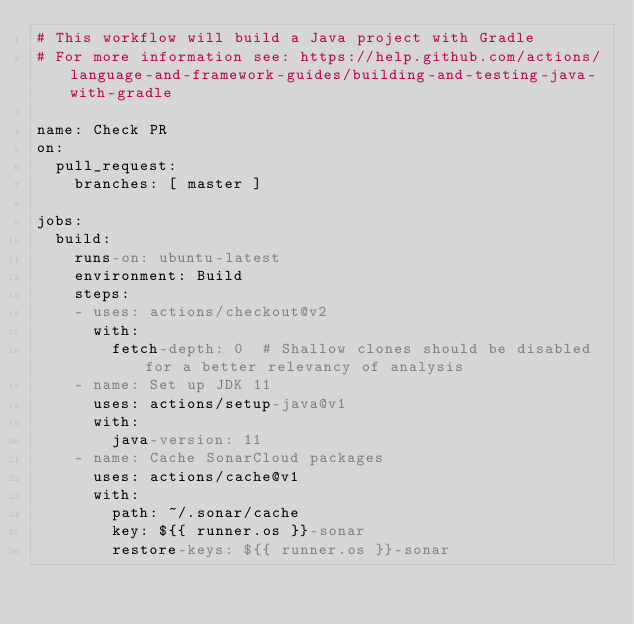Convert code to text. <code><loc_0><loc_0><loc_500><loc_500><_YAML_># This workflow will build a Java project with Gradle
# For more information see: https://help.github.com/actions/language-and-framework-guides/building-and-testing-java-with-gradle

name: Check PR
on:
  pull_request:
    branches: [ master ]

jobs:
  build:
    runs-on: ubuntu-latest
    environment: Build
    steps:
    - uses: actions/checkout@v2
      with:
        fetch-depth: 0  # Shallow clones should be disabled for a better relevancy of analysis
    - name: Set up JDK 11
      uses: actions/setup-java@v1
      with:
        java-version: 11
    - name: Cache SonarCloud packages
      uses: actions/cache@v1
      with:
        path: ~/.sonar/cache
        key: ${{ runner.os }}-sonar
        restore-keys: ${{ runner.os }}-sonar</code> 